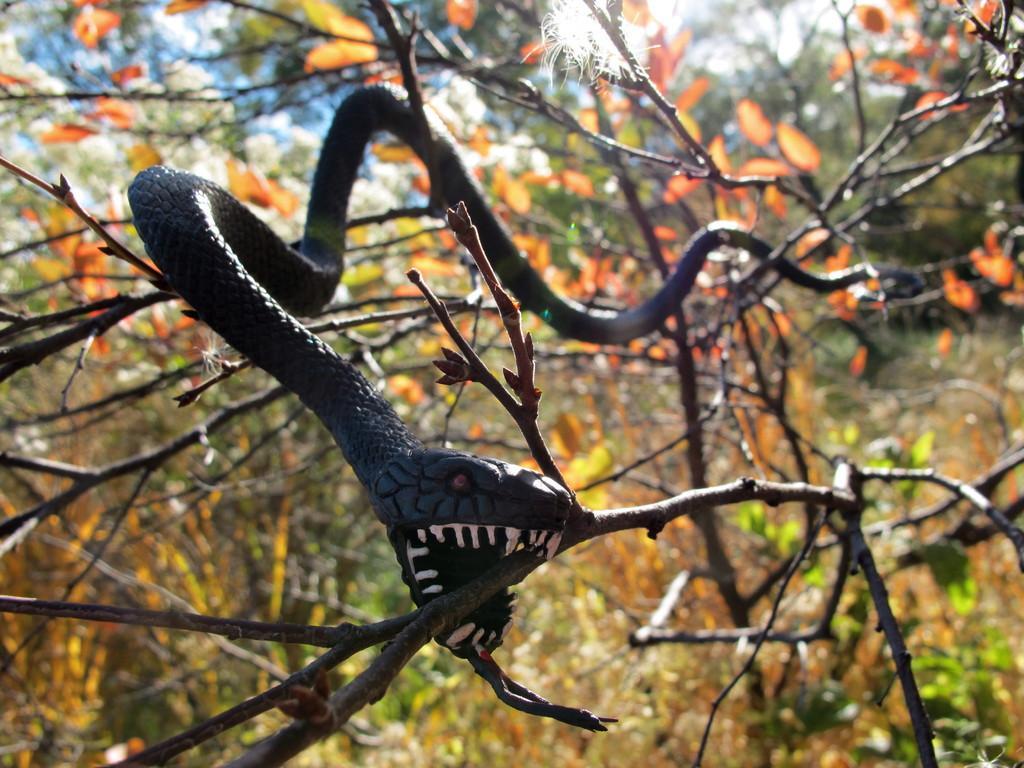Describe this image in one or two sentences. In this image there is a snake on a tree. There are leaves on the tree. At the top there is the sky. The snake seems to be a toy. 